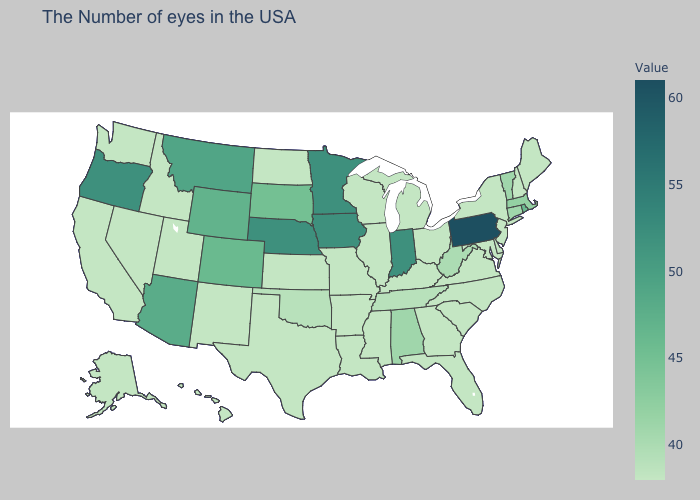Which states have the lowest value in the West?
Keep it brief. New Mexico, Utah, Idaho, Nevada, California, Washington, Alaska, Hawaii. Does Pennsylvania have the highest value in the USA?
Answer briefly. Yes. Does Idaho have a lower value than Minnesota?
Write a very short answer. Yes. Which states hav the highest value in the West?
Give a very brief answer. Oregon. Does Pennsylvania have the highest value in the USA?
Quick response, please. Yes. Among the states that border North Dakota , does Montana have the highest value?
Answer briefly. No. 